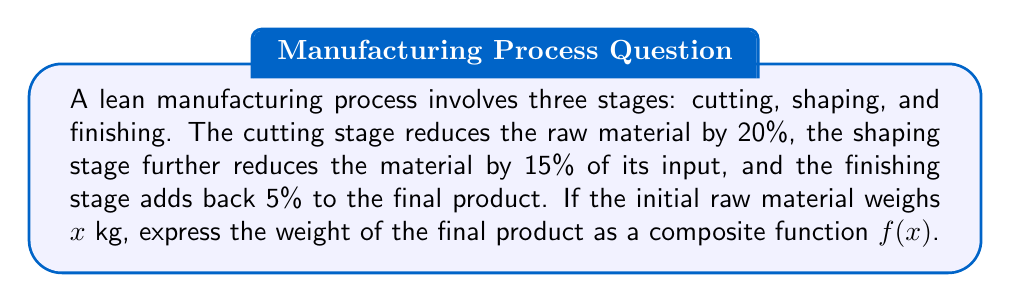Can you solve this math problem? Let's break this down step-by-step:

1) First, let's define functions for each stage:

   Cutting: $g(x) = 0.8x$ (reduces by 20%, so 80% remains)
   Shaping: $h(x) = 0.85x$ (reduces by 15%, so 85% remains)
   Finishing: $k(x) = 1.05x$ (increases by 5%)

2) Now, we need to compose these functions in the order they are applied:

   $f(x) = k(h(g(x)))$

3) Let's work from the inside out:

   $g(x) = 0.8x$
   $h(g(x)) = h(0.8x) = 0.85(0.8x) = 0.68x$
   $f(x) = k(h(g(x))) = k(0.68x) = 1.05(0.68x) = 0.714x$

4) Therefore, the composite function is:

   $f(x) = 0.714x$

This means that the final product weighs 71.4% of the initial raw material weight.
Answer: $f(x) = 0.714x$ 